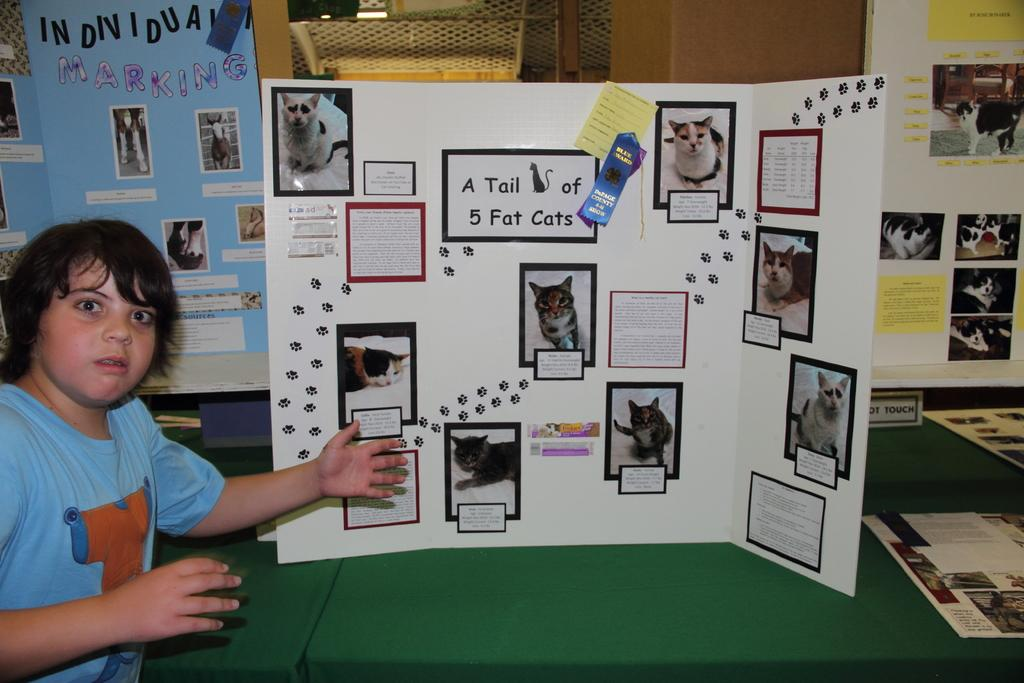<image>
Share a concise interpretation of the image provided. A kid in front of a cardboard display that says A Tail of 5 Fat cats. 